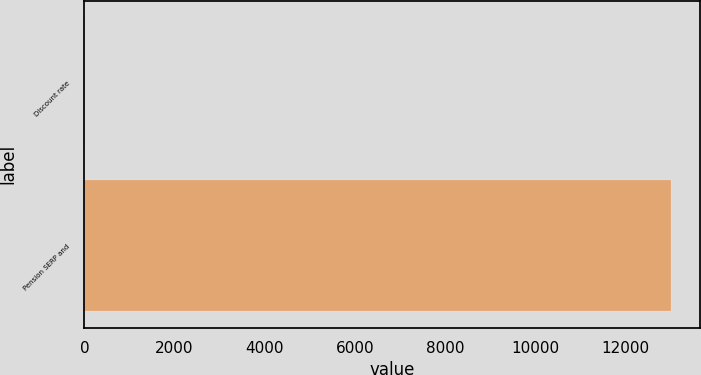Convert chart to OTSL. <chart><loc_0><loc_0><loc_500><loc_500><bar_chart><fcel>Discount rate<fcel>Pension SERP and<nl><fcel>3.98<fcel>13007<nl></chart> 